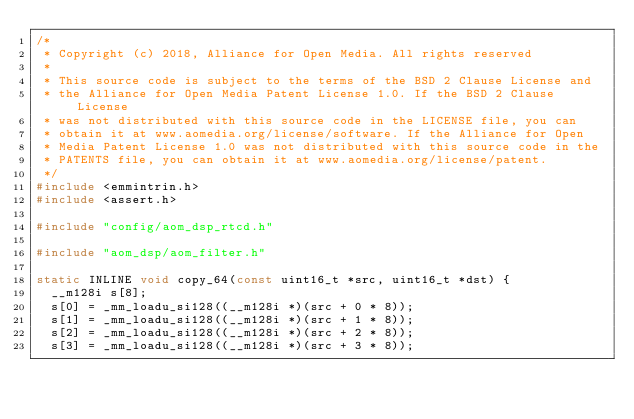<code> <loc_0><loc_0><loc_500><loc_500><_C_>/*
 * Copyright (c) 2018, Alliance for Open Media. All rights reserved
 *
 * This source code is subject to the terms of the BSD 2 Clause License and
 * the Alliance for Open Media Patent License 1.0. If the BSD 2 Clause License
 * was not distributed with this source code in the LICENSE file, you can
 * obtain it at www.aomedia.org/license/software. If the Alliance for Open
 * Media Patent License 1.0 was not distributed with this source code in the
 * PATENTS file, you can obtain it at www.aomedia.org/license/patent.
 */
#include <emmintrin.h>
#include <assert.h>

#include "config/aom_dsp_rtcd.h"

#include "aom_dsp/aom_filter.h"

static INLINE void copy_64(const uint16_t *src, uint16_t *dst) {
  __m128i s[8];
  s[0] = _mm_loadu_si128((__m128i *)(src + 0 * 8));
  s[1] = _mm_loadu_si128((__m128i *)(src + 1 * 8));
  s[2] = _mm_loadu_si128((__m128i *)(src + 2 * 8));
  s[3] = _mm_loadu_si128((__m128i *)(src + 3 * 8));</code> 